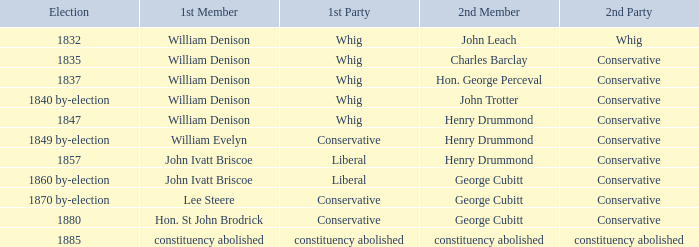In the election held in 1832, to which party does the first member, william denison, belong? Whig. 